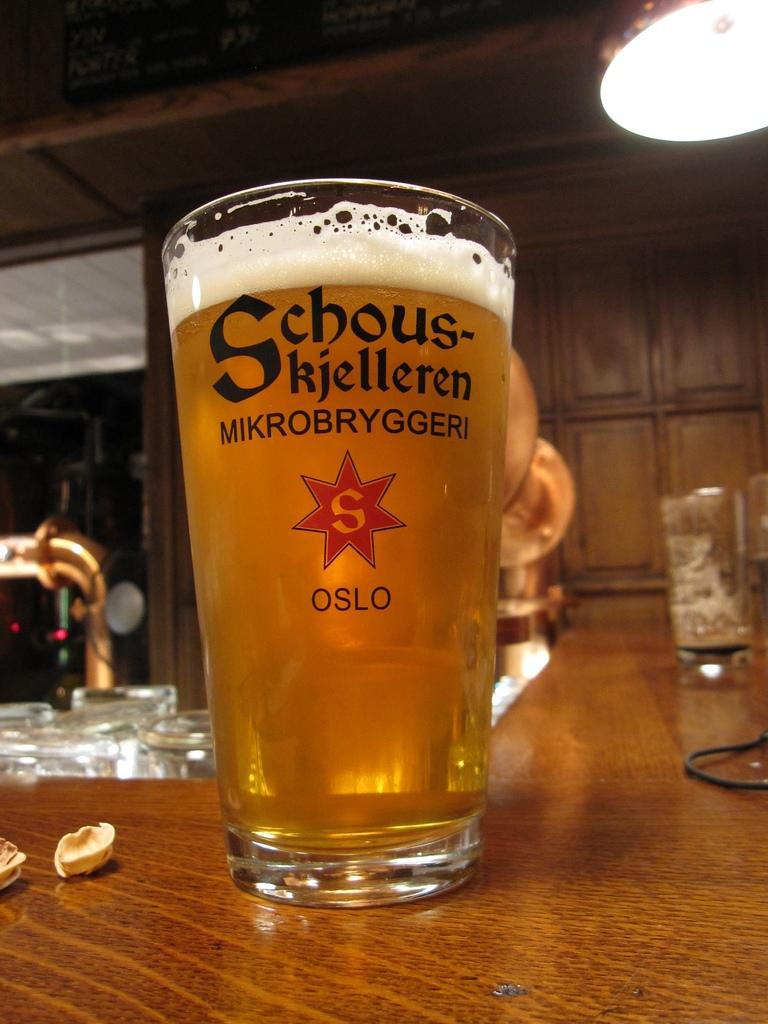<image>
Write a terse but informative summary of the picture. Large full cup of beer with the name "Mikrobryggeri" on it. 